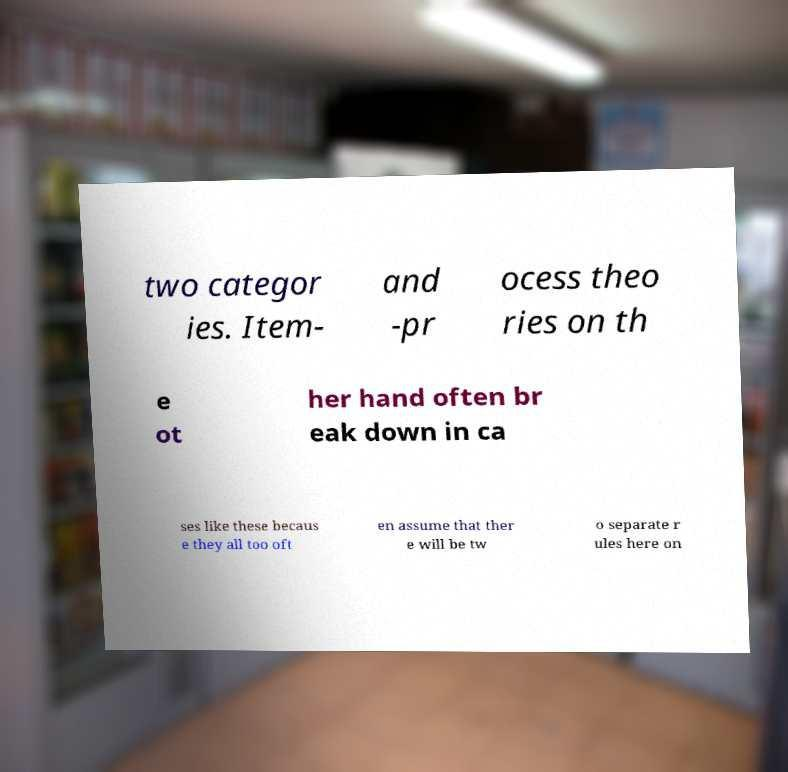I need the written content from this picture converted into text. Can you do that? two categor ies. Item- and -pr ocess theo ries on th e ot her hand often br eak down in ca ses like these becaus e they all too oft en assume that ther e will be tw o separate r ules here on 